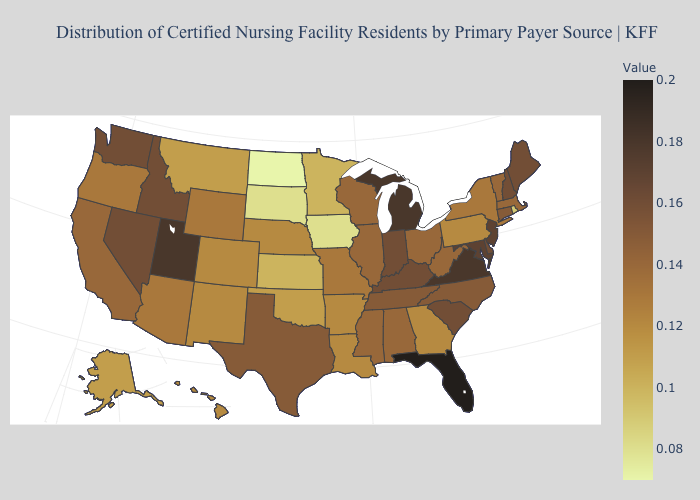Among the states that border South Carolina , which have the highest value?
Answer briefly. North Carolina. Does Florida have the highest value in the USA?
Short answer required. Yes. Which states have the highest value in the USA?
Give a very brief answer. Florida. Which states have the lowest value in the USA?
Keep it brief. North Dakota. Does Florida have the lowest value in the South?
Keep it brief. No. Which states hav the highest value in the MidWest?
Be succinct. Michigan. Which states have the lowest value in the USA?
Be succinct. North Dakota. Does Michigan have the highest value in the MidWest?
Keep it brief. Yes. 